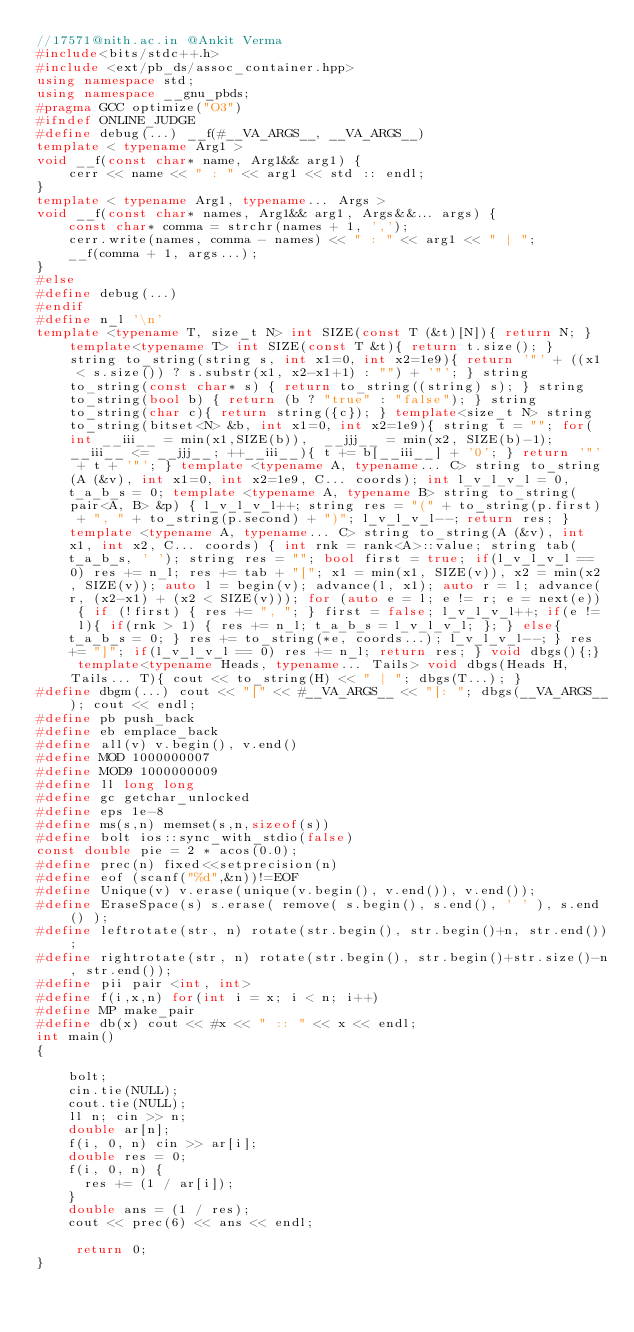Convert code to text. <code><loc_0><loc_0><loc_500><loc_500><_C++_>//17571@nith.ac.in @Ankit Verma
#include<bits/stdc++.h>
#include <ext/pb_ds/assoc_container.hpp>
using namespace std;
using namespace __gnu_pbds;
#pragma GCC optimize("O3")
#ifndef ONLINE_JUDGE
#define debug(...) __f(#__VA_ARGS__, __VA_ARGS__)
template < typename Arg1 >
void __f(const char* name, Arg1&& arg1) {
    cerr << name << " : " << arg1 << std :: endl;
}
template < typename Arg1, typename... Args >
void __f(const char* names, Arg1&& arg1, Args&&... args) {
    const char* comma = strchr(names + 1, ',');
    cerr.write(names, comma - names) << " : " << arg1 << " | ";
    __f(comma + 1, args...);
}
#else
#define debug(...)
#endif
#define n_l '\n'
template <typename T, size_t N> int SIZE(const T (&t)[N]){ return N; } template<typename T> int SIZE(const T &t){ return t.size(); } string to_string(string s, int x1=0, int x2=1e9){ return '"' + ((x1 < s.size()) ? s.substr(x1, x2-x1+1) : "") + '"'; } string to_string(const char* s) { return to_string((string) s); } string to_string(bool b) { return (b ? "true" : "false"); } string to_string(char c){ return string({c}); } template<size_t N> string to_string(bitset<N> &b, int x1=0, int x2=1e9){ string t = ""; for(int __iii__ = min(x1,SIZE(b)),  __jjj__ = min(x2, SIZE(b)-1); __iii__ <= __jjj__; ++__iii__){ t += b[__iii__] + '0'; } return '"' + t + '"'; } template <typename A, typename... C> string to_string(A (&v), int x1=0, int x2=1e9, C... coords); int l_v_l_v_l = 0, t_a_b_s = 0; template <typename A, typename B> string to_string(pair<A, B> &p) { l_v_l_v_l++; string res = "(" + to_string(p.first) + ", " + to_string(p.second) + ")"; l_v_l_v_l--; return res; } template <typename A, typename... C> string to_string(A (&v), int x1, int x2, C... coords) { int rnk = rank<A>::value; string tab(t_a_b_s, ' '); string res = ""; bool first = true; if(l_v_l_v_l == 0) res += n_l; res += tab + "["; x1 = min(x1, SIZE(v)), x2 = min(x2, SIZE(v)); auto l = begin(v); advance(l, x1); auto r = l; advance(r, (x2-x1) + (x2 < SIZE(v))); for (auto e = l; e != r; e = next(e)) { if (!first) { res += ", "; } first = false; l_v_l_v_l++; if(e != l){ if(rnk > 1) { res += n_l; t_a_b_s = l_v_l_v_l; }; } else{ t_a_b_s = 0; } res += to_string(*e, coords...); l_v_l_v_l--; } res += "]"; if(l_v_l_v_l == 0) res += n_l; return res; } void dbgs(){;} template<typename Heads, typename... Tails> void dbgs(Heads H, Tails... T){ cout << to_string(H) << " | "; dbgs(T...); }
#define dbgm(...) cout << "[" << #__VA_ARGS__ << "]: "; dbgs(__VA_ARGS__); cout << endl;
#define pb push_back
#define eb emplace_back
#define all(v) v.begin(), v.end()
#define MOD 1000000007
#define MOD9 1000000009
#define ll long long
#define gc getchar_unlocked
#define eps 1e-8
#define ms(s,n) memset(s,n,sizeof(s))
#define bolt ios::sync_with_stdio(false)
const double pie = 2 * acos(0.0);
#define prec(n) fixed<<setprecision(n)
#define eof (scanf("%d",&n))!=EOF
#define Unique(v) v.erase(unique(v.begin(), v.end()), v.end());
#define EraseSpace(s) s.erase( remove( s.begin(), s.end(), ' ' ), s.end() );
#define leftrotate(str, n) rotate(str.begin(), str.begin()+n, str.end());
#define rightrotate(str, n) rotate(str.begin(), str.begin()+str.size()-n, str.end());
#define pii pair <int, int> 
#define f(i,x,n) for(int i = x; i < n; i++)
#define MP make_pair
#define db(x) cout << #x << " :: " << x << endl;
int main()
{  
    
    bolt; 
    cin.tie(NULL);
    cout.tie(NULL);
    ll n; cin >> n;
    double ar[n];
    f(i, 0, n) cin >> ar[i];
    double res = 0;
    f(i, 0, n) {
    	res += (1 / ar[i]);
    }
    double ans = (1 / res);
    cout << prec(6) << ans << endl;

     return 0;
}</code> 